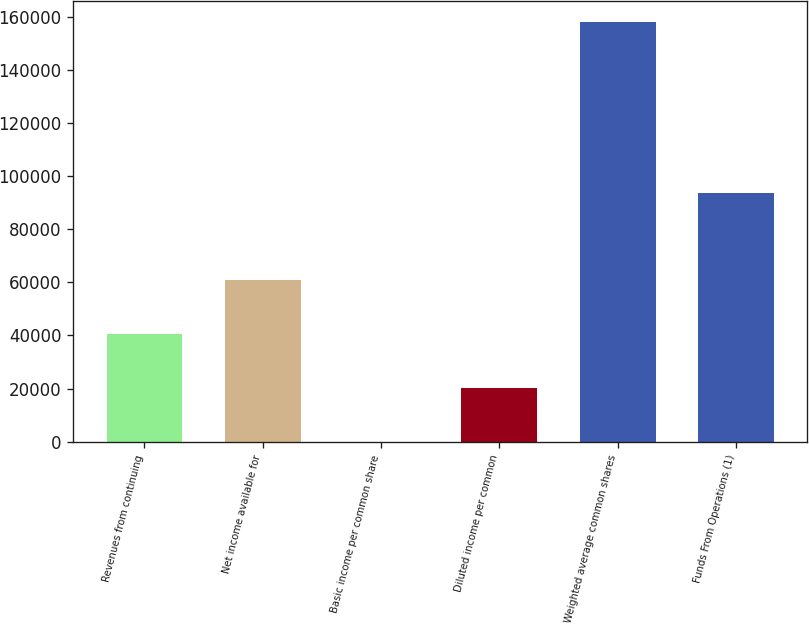<chart> <loc_0><loc_0><loc_500><loc_500><bar_chart><fcel>Revenues from continuing<fcel>Net income available for<fcel>Basic income per common share<fcel>Diluted income per common<fcel>Weighted average common shares<fcel>Funds From Operations (1)<nl><fcel>40560.1<fcel>60840<fcel>0.39<fcel>20280.2<fcel>157856<fcel>93673<nl></chart> 